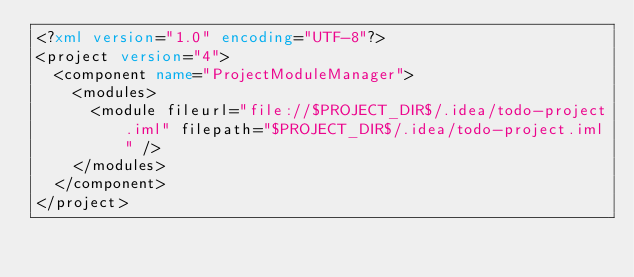Convert code to text. <code><loc_0><loc_0><loc_500><loc_500><_XML_><?xml version="1.0" encoding="UTF-8"?>
<project version="4">
  <component name="ProjectModuleManager">
    <modules>
      <module fileurl="file://$PROJECT_DIR$/.idea/todo-project.iml" filepath="$PROJECT_DIR$/.idea/todo-project.iml" />
    </modules>
  </component>
</project></code> 